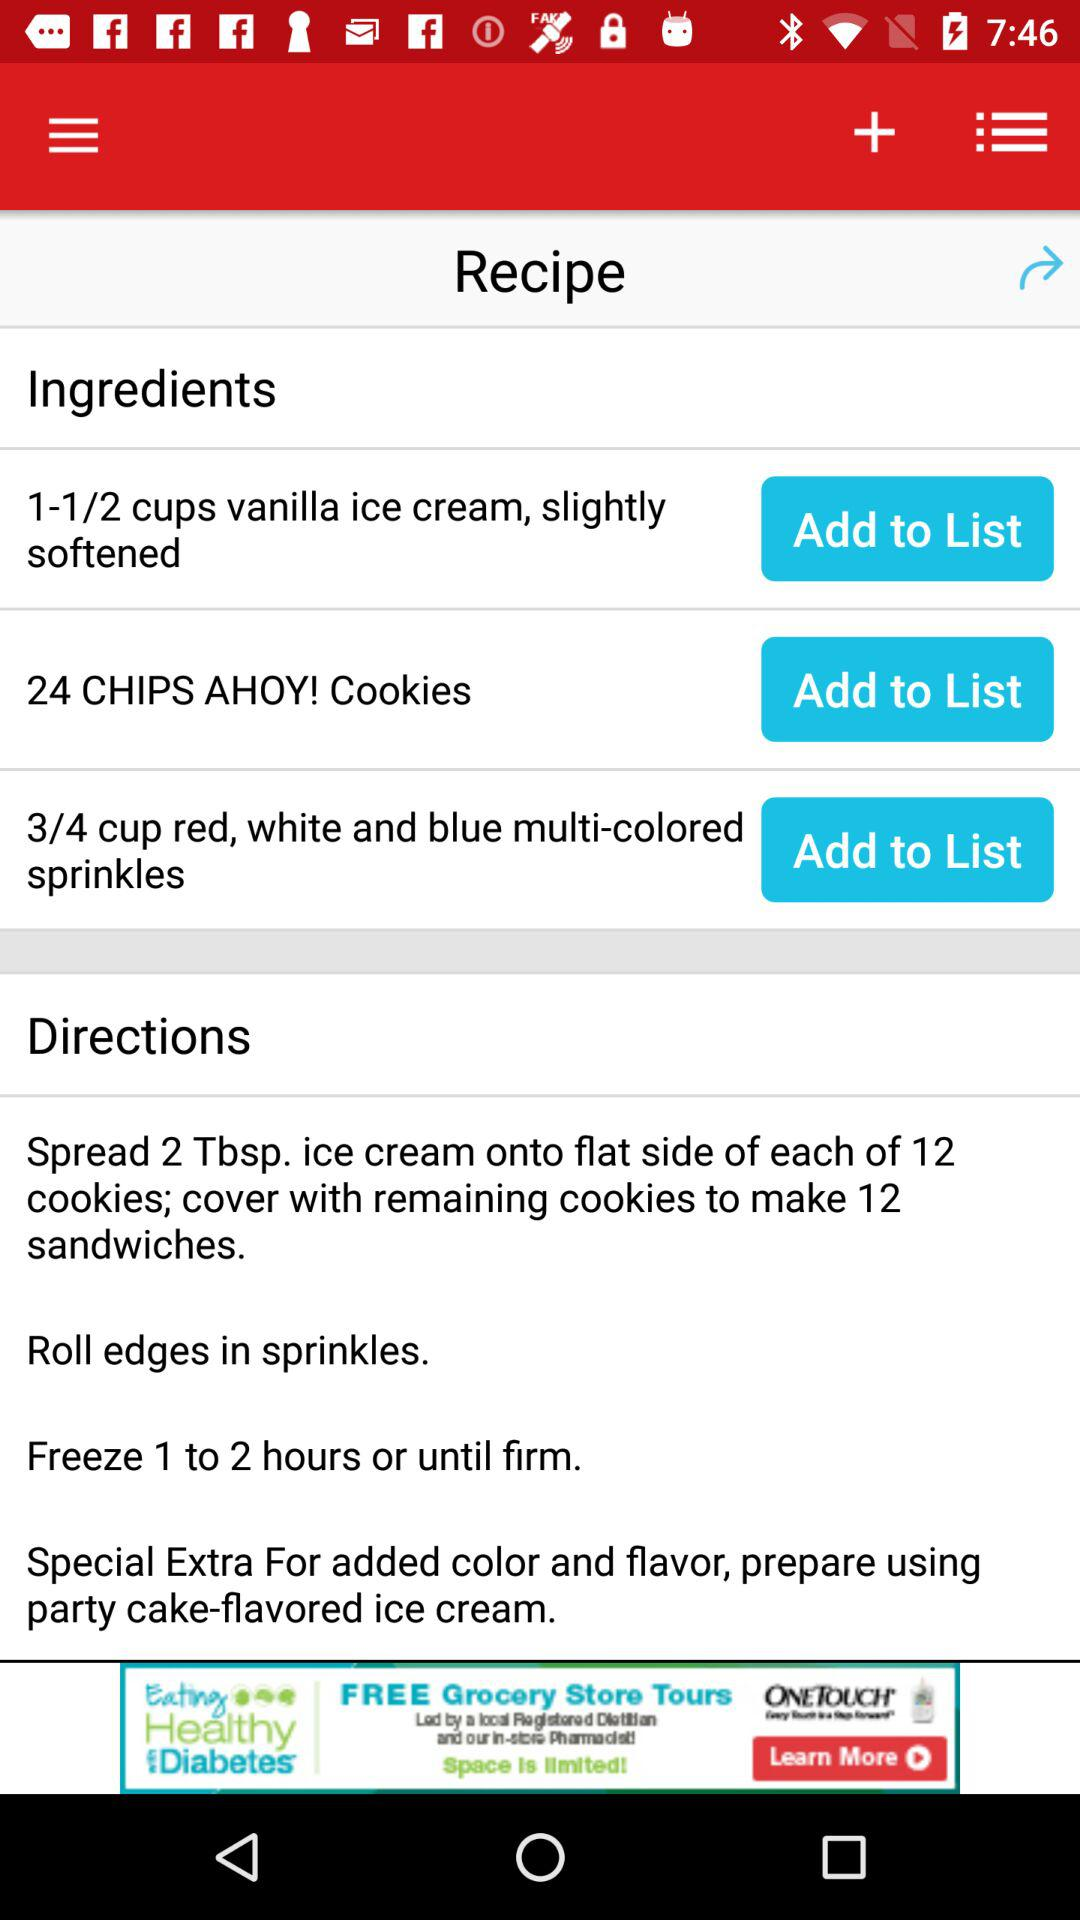What are the ingredients available for the recipe? The ingredients available for the recipe are 1-1/2 cups of slightly softened vanilla ice cream,24 "CHIPS AHOY!" Cookies and 3/4 cup of multicolored red, white, and blue sprinkles. 